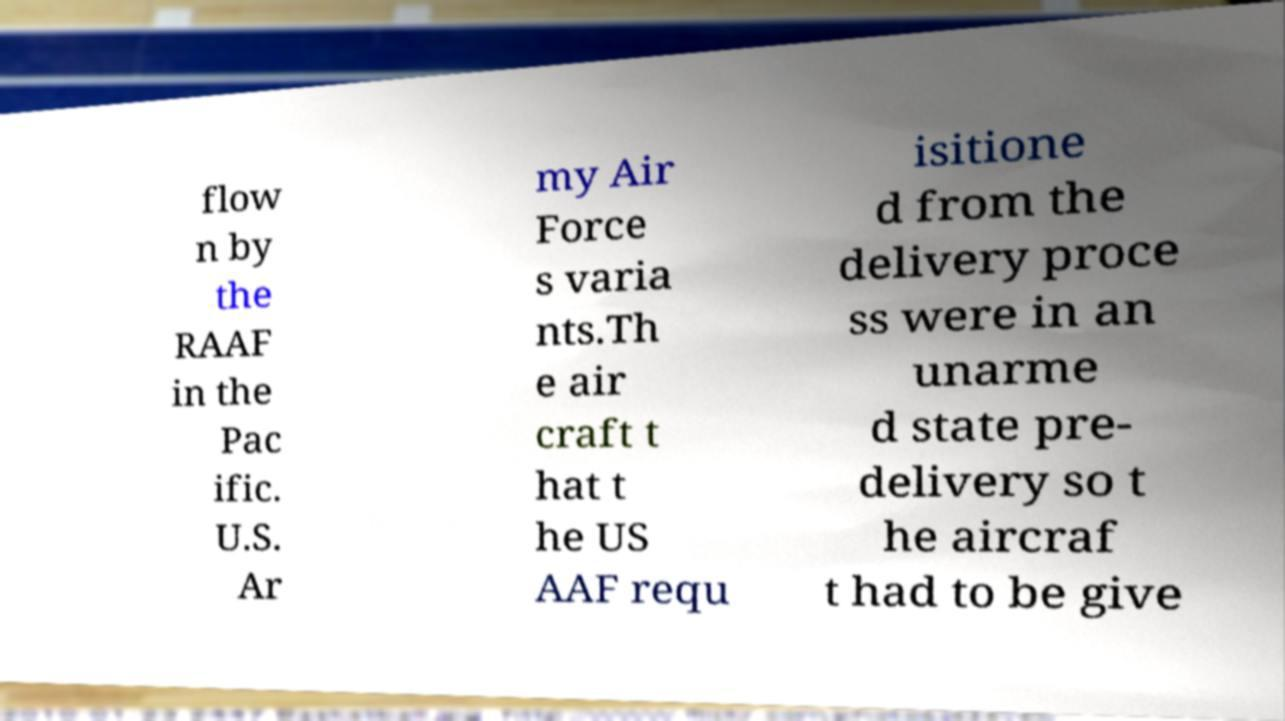Could you assist in decoding the text presented in this image and type it out clearly? flow n by the RAAF in the Pac ific. U.S. Ar my Air Force s varia nts.Th e air craft t hat t he US AAF requ isitione d from the delivery proce ss were in an unarme d state pre- delivery so t he aircraf t had to be give 